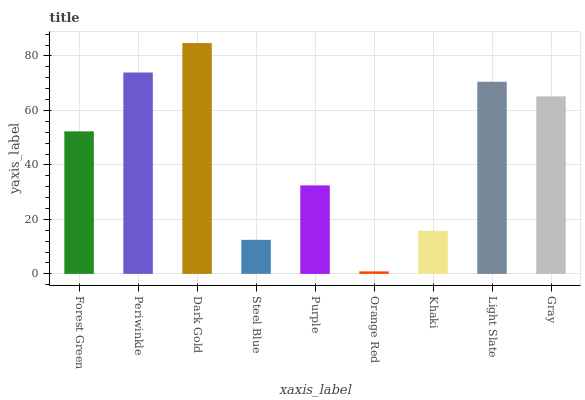Is Periwinkle the minimum?
Answer yes or no. No. Is Periwinkle the maximum?
Answer yes or no. No. Is Periwinkle greater than Forest Green?
Answer yes or no. Yes. Is Forest Green less than Periwinkle?
Answer yes or no. Yes. Is Forest Green greater than Periwinkle?
Answer yes or no. No. Is Periwinkle less than Forest Green?
Answer yes or no. No. Is Forest Green the high median?
Answer yes or no. Yes. Is Forest Green the low median?
Answer yes or no. Yes. Is Dark Gold the high median?
Answer yes or no. No. Is Steel Blue the low median?
Answer yes or no. No. 